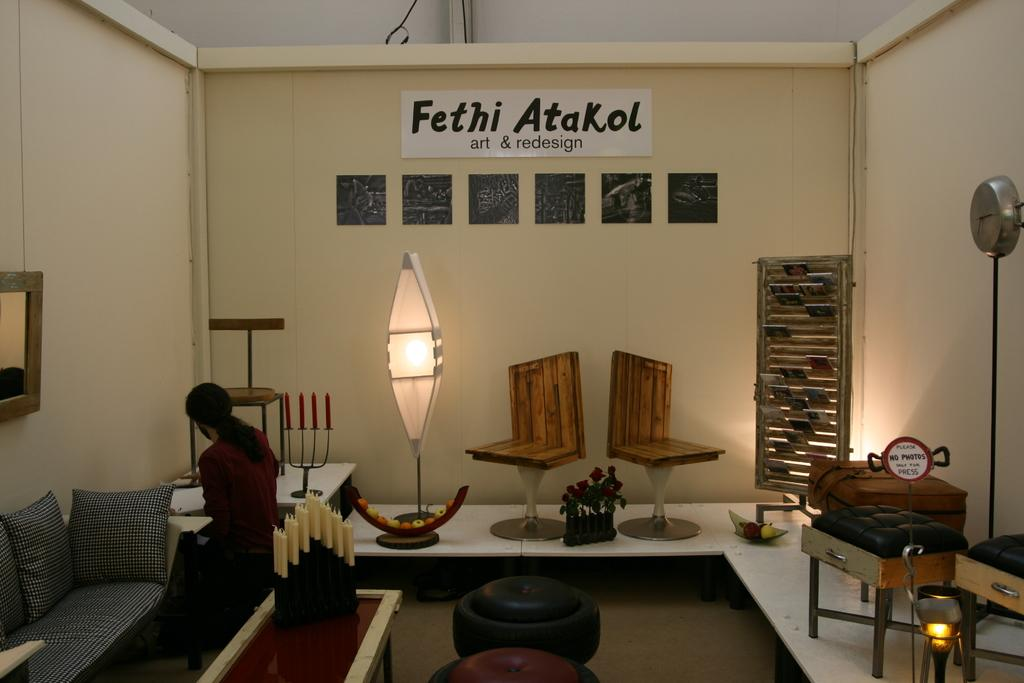<image>
Write a terse but informative summary of the picture. A room which has words Fethi Atakol on the wall. 